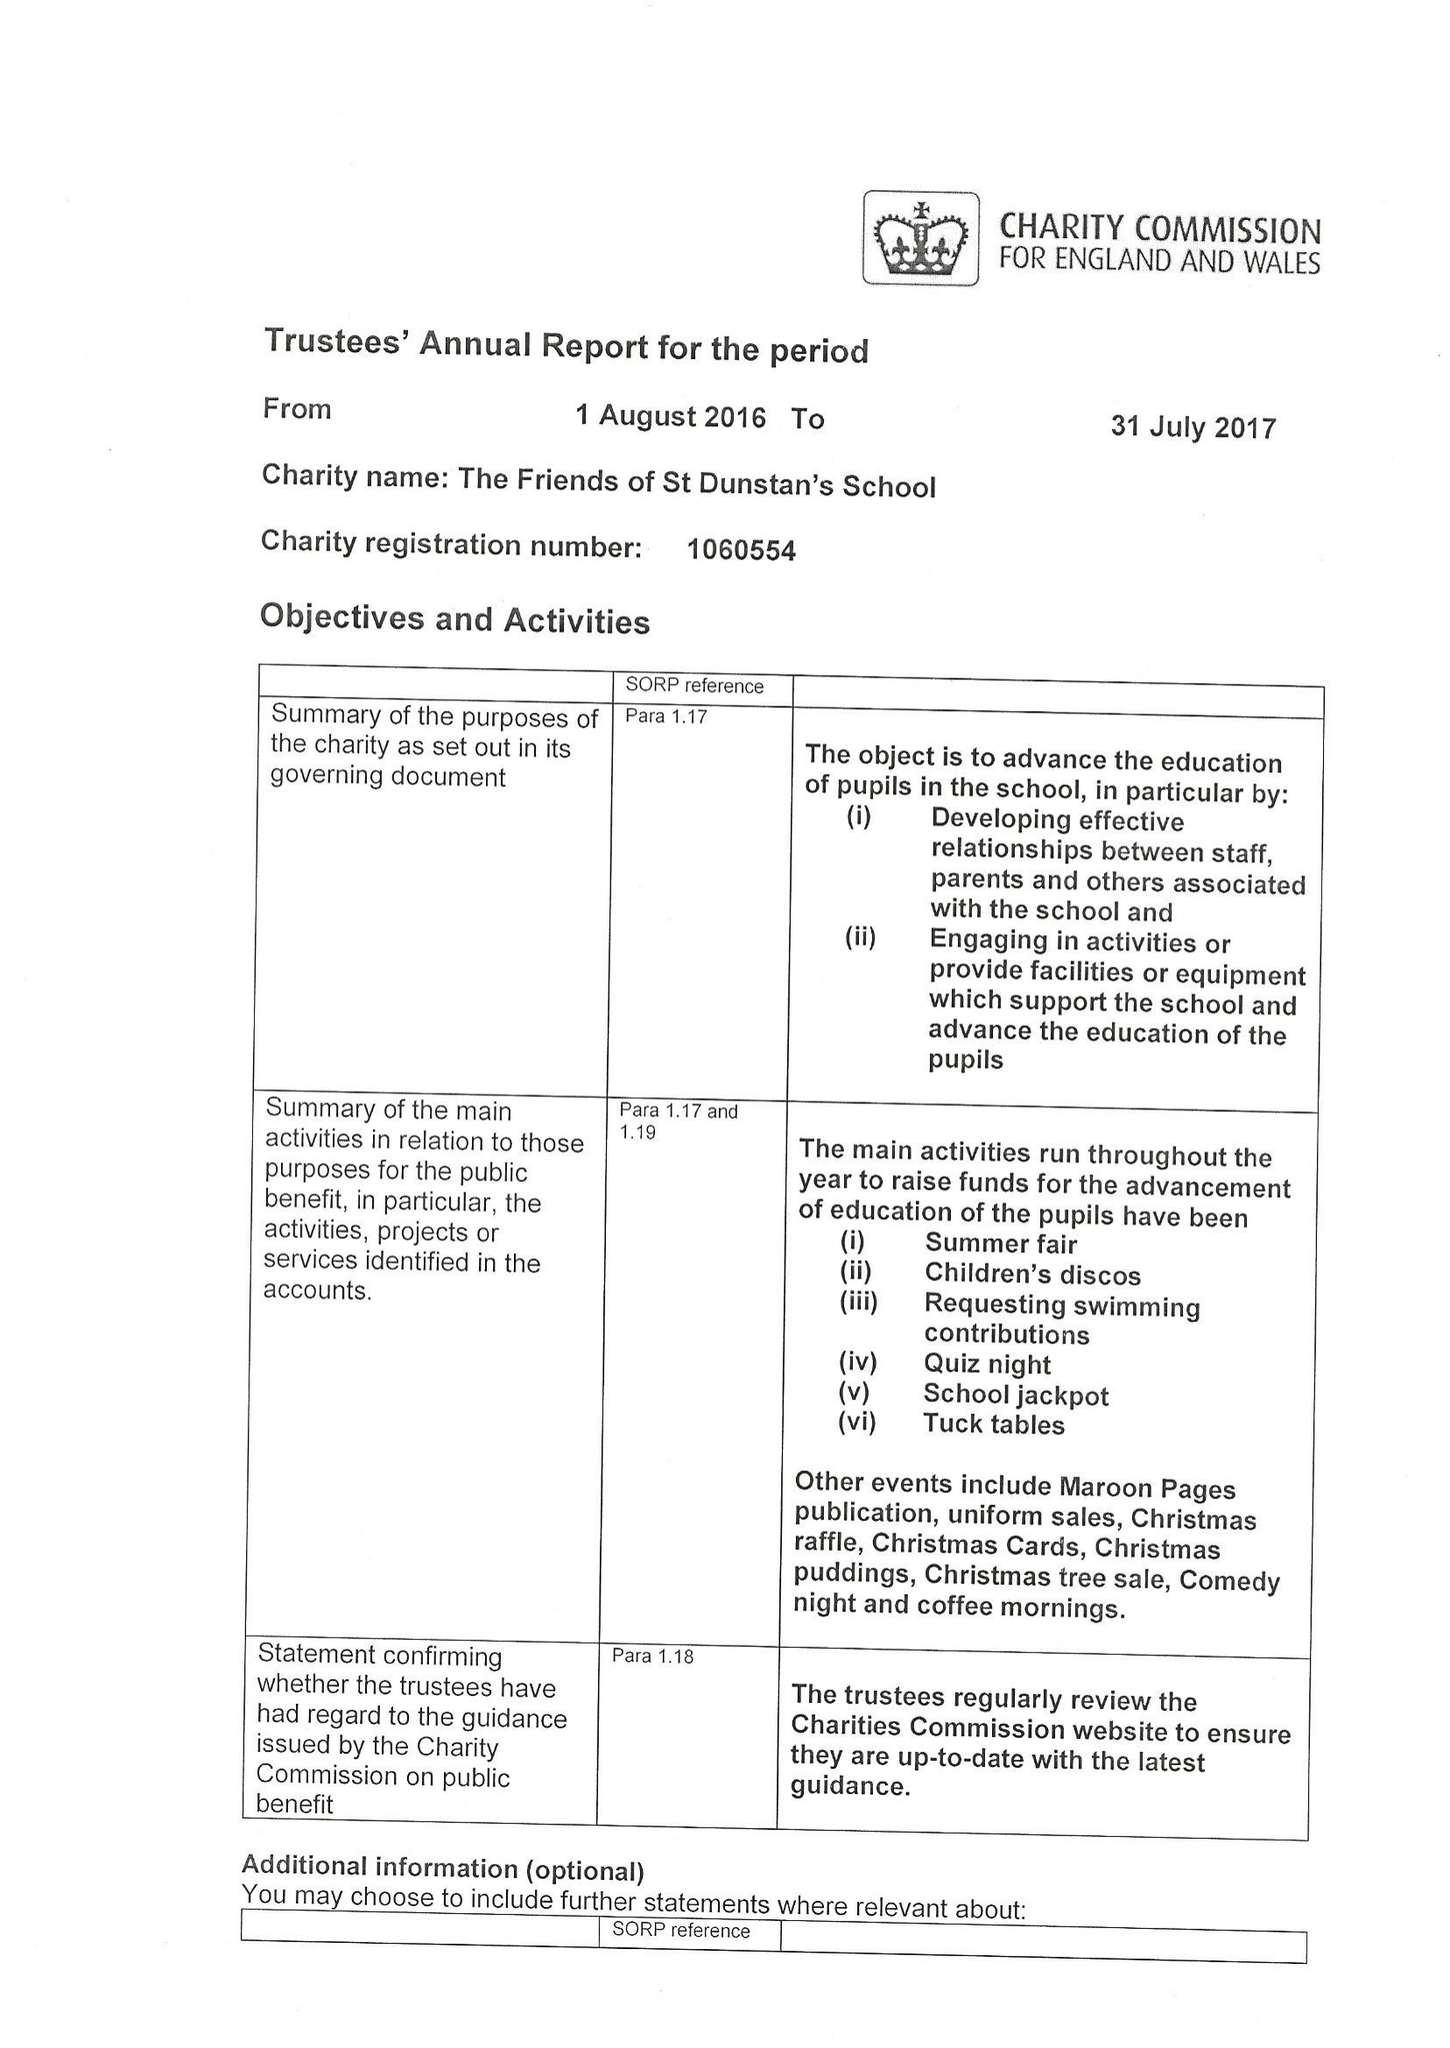What is the value for the address__street_line?
Answer the question using a single word or phrase. ONSLOW CRESCENT 